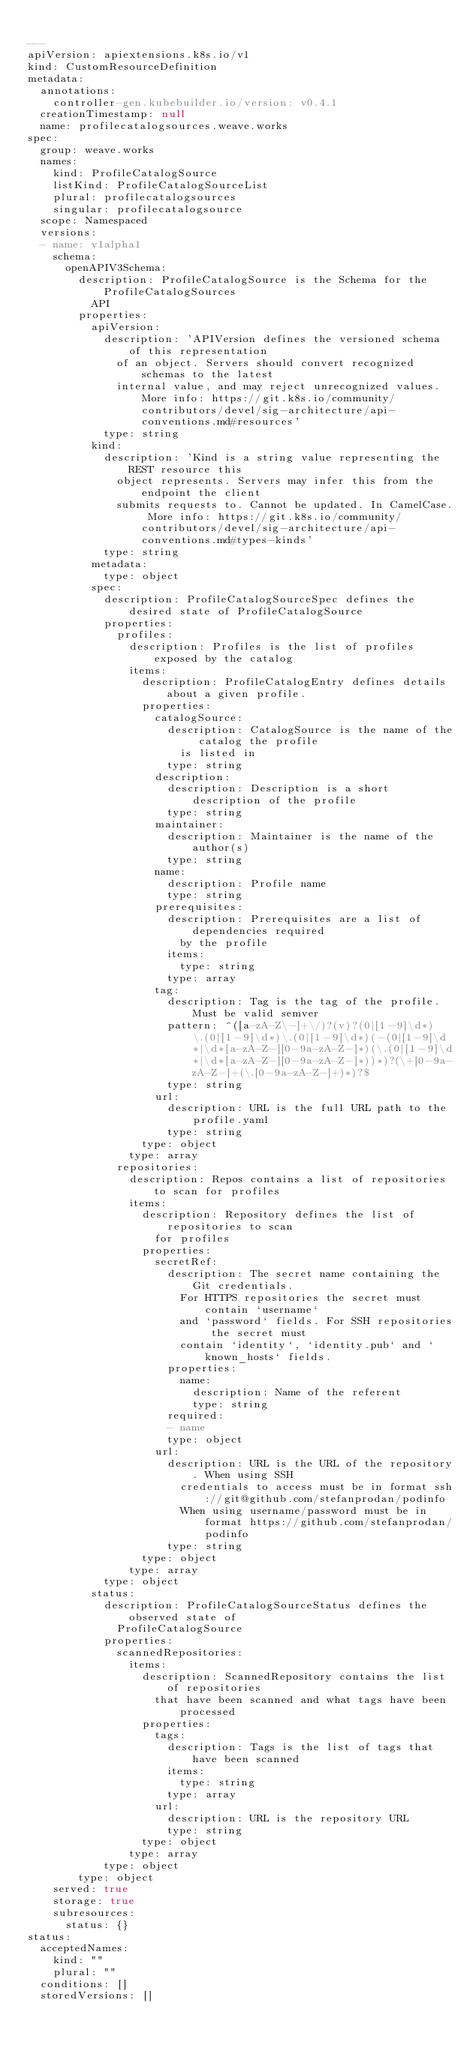Convert code to text. <code><loc_0><loc_0><loc_500><loc_500><_YAML_>
---
apiVersion: apiextensions.k8s.io/v1
kind: CustomResourceDefinition
metadata:
  annotations:
    controller-gen.kubebuilder.io/version: v0.4.1
  creationTimestamp: null
  name: profilecatalogsources.weave.works
spec:
  group: weave.works
  names:
    kind: ProfileCatalogSource
    listKind: ProfileCatalogSourceList
    plural: profilecatalogsources
    singular: profilecatalogsource
  scope: Namespaced
  versions:
  - name: v1alpha1
    schema:
      openAPIV3Schema:
        description: ProfileCatalogSource is the Schema for the ProfileCatalogSources
          API
        properties:
          apiVersion:
            description: 'APIVersion defines the versioned schema of this representation
              of an object. Servers should convert recognized schemas to the latest
              internal value, and may reject unrecognized values. More info: https://git.k8s.io/community/contributors/devel/sig-architecture/api-conventions.md#resources'
            type: string
          kind:
            description: 'Kind is a string value representing the REST resource this
              object represents. Servers may infer this from the endpoint the client
              submits requests to. Cannot be updated. In CamelCase. More info: https://git.k8s.io/community/contributors/devel/sig-architecture/api-conventions.md#types-kinds'
            type: string
          metadata:
            type: object
          spec:
            description: ProfileCatalogSourceSpec defines the desired state of ProfileCatalogSource
            properties:
              profiles:
                description: Profiles is the list of profiles exposed by the catalog
                items:
                  description: ProfileCatalogEntry defines details about a given profile.
                  properties:
                    catalogSource:
                      description: CatalogSource is the name of the catalog the profile
                        is listed in
                      type: string
                    description:
                      description: Description is a short description of the profile
                      type: string
                    maintainer:
                      description: Maintainer is the name of the author(s)
                      type: string
                    name:
                      description: Profile name
                      type: string
                    prerequisites:
                      description: Prerequisites are a list of dependencies required
                        by the profile
                      items:
                        type: string
                      type: array
                    tag:
                      description: Tag is the tag of the profile. Must be valid semver
                      pattern: ^([a-zA-Z\-]+\/)?(v)?(0|[1-9]\d*)\.(0|[1-9]\d*)\.(0|[1-9]\d*)(-(0|[1-9]\d*|\d*[a-zA-Z-][0-9a-zA-Z-]*)(\.(0|[1-9]\d*|\d*[a-zA-Z-][0-9a-zA-Z-]*))*)?(\+[0-9a-zA-Z-]+(\.[0-9a-zA-Z-]+)*)?$
                      type: string
                    url:
                      description: URL is the full URL path to the profile.yaml
                      type: string
                  type: object
                type: array
              repositories:
                description: Repos contains a list of repositories to scan for profiles
                items:
                  description: Repository defines the list of repositories to scan
                    for profiles
                  properties:
                    secretRef:
                      description: The secret name containing the Git credentials.
                        For HTTPS repositories the secret must contain `username`
                        and `password` fields. For SSH repositories the secret must
                        contain `identity`, `identity.pub` and `known_hosts` fields.
                      properties:
                        name:
                          description: Name of the referent
                          type: string
                      required:
                      - name
                      type: object
                    url:
                      description: URL is the URL of the repository. When using SSH
                        credentials to access must be in format ssh://git@github.com/stefanprodan/podinfo
                        When using username/password must be in format https://github.com/stefanprodan/podinfo
                      type: string
                  type: object
                type: array
            type: object
          status:
            description: ProfileCatalogSourceStatus defines the observed state of
              ProfileCatalogSource
            properties:
              scannedRepositories:
                items:
                  description: ScannedRepository contains the list of repositories
                    that have been scanned and what tags have been processed
                  properties:
                    tags:
                      description: Tags is the list of tags that have been scanned
                      items:
                        type: string
                      type: array
                    url:
                      description: URL is the repository URL
                      type: string
                  type: object
                type: array
            type: object
        type: object
    served: true
    storage: true
    subresources:
      status: {}
status:
  acceptedNames:
    kind: ""
    plural: ""
  conditions: []
  storedVersions: []
</code> 